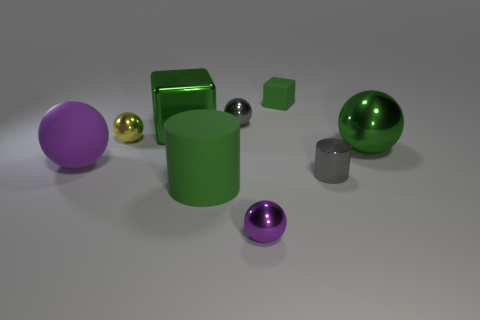What is the material of the purple object that is in front of the matte thing that is left of the big green cylinder?
Ensure brevity in your answer.  Metal. There is a purple thing right of the large green matte cylinder that is in front of the gray cylinder on the right side of the big purple rubber ball; what shape is it?
Provide a succinct answer. Sphere. What material is the tiny gray thing that is the same shape as the tiny yellow metal thing?
Give a very brief answer. Metal. What number of gray spheres are there?
Make the answer very short. 1. What shape is the purple thing that is behind the big green rubber cylinder?
Your answer should be compact. Sphere. There is a ball behind the green metallic thing that is left of the big green object that is right of the small green block; what color is it?
Ensure brevity in your answer.  Gray. There is a tiny purple object that is the same material as the large green block; what shape is it?
Your response must be concise. Sphere. Are there fewer small matte things than large metallic cylinders?
Make the answer very short. No. Are the big green sphere and the big cylinder made of the same material?
Make the answer very short. No. What number of other objects are the same color as the tiny rubber object?
Offer a terse response. 3. 